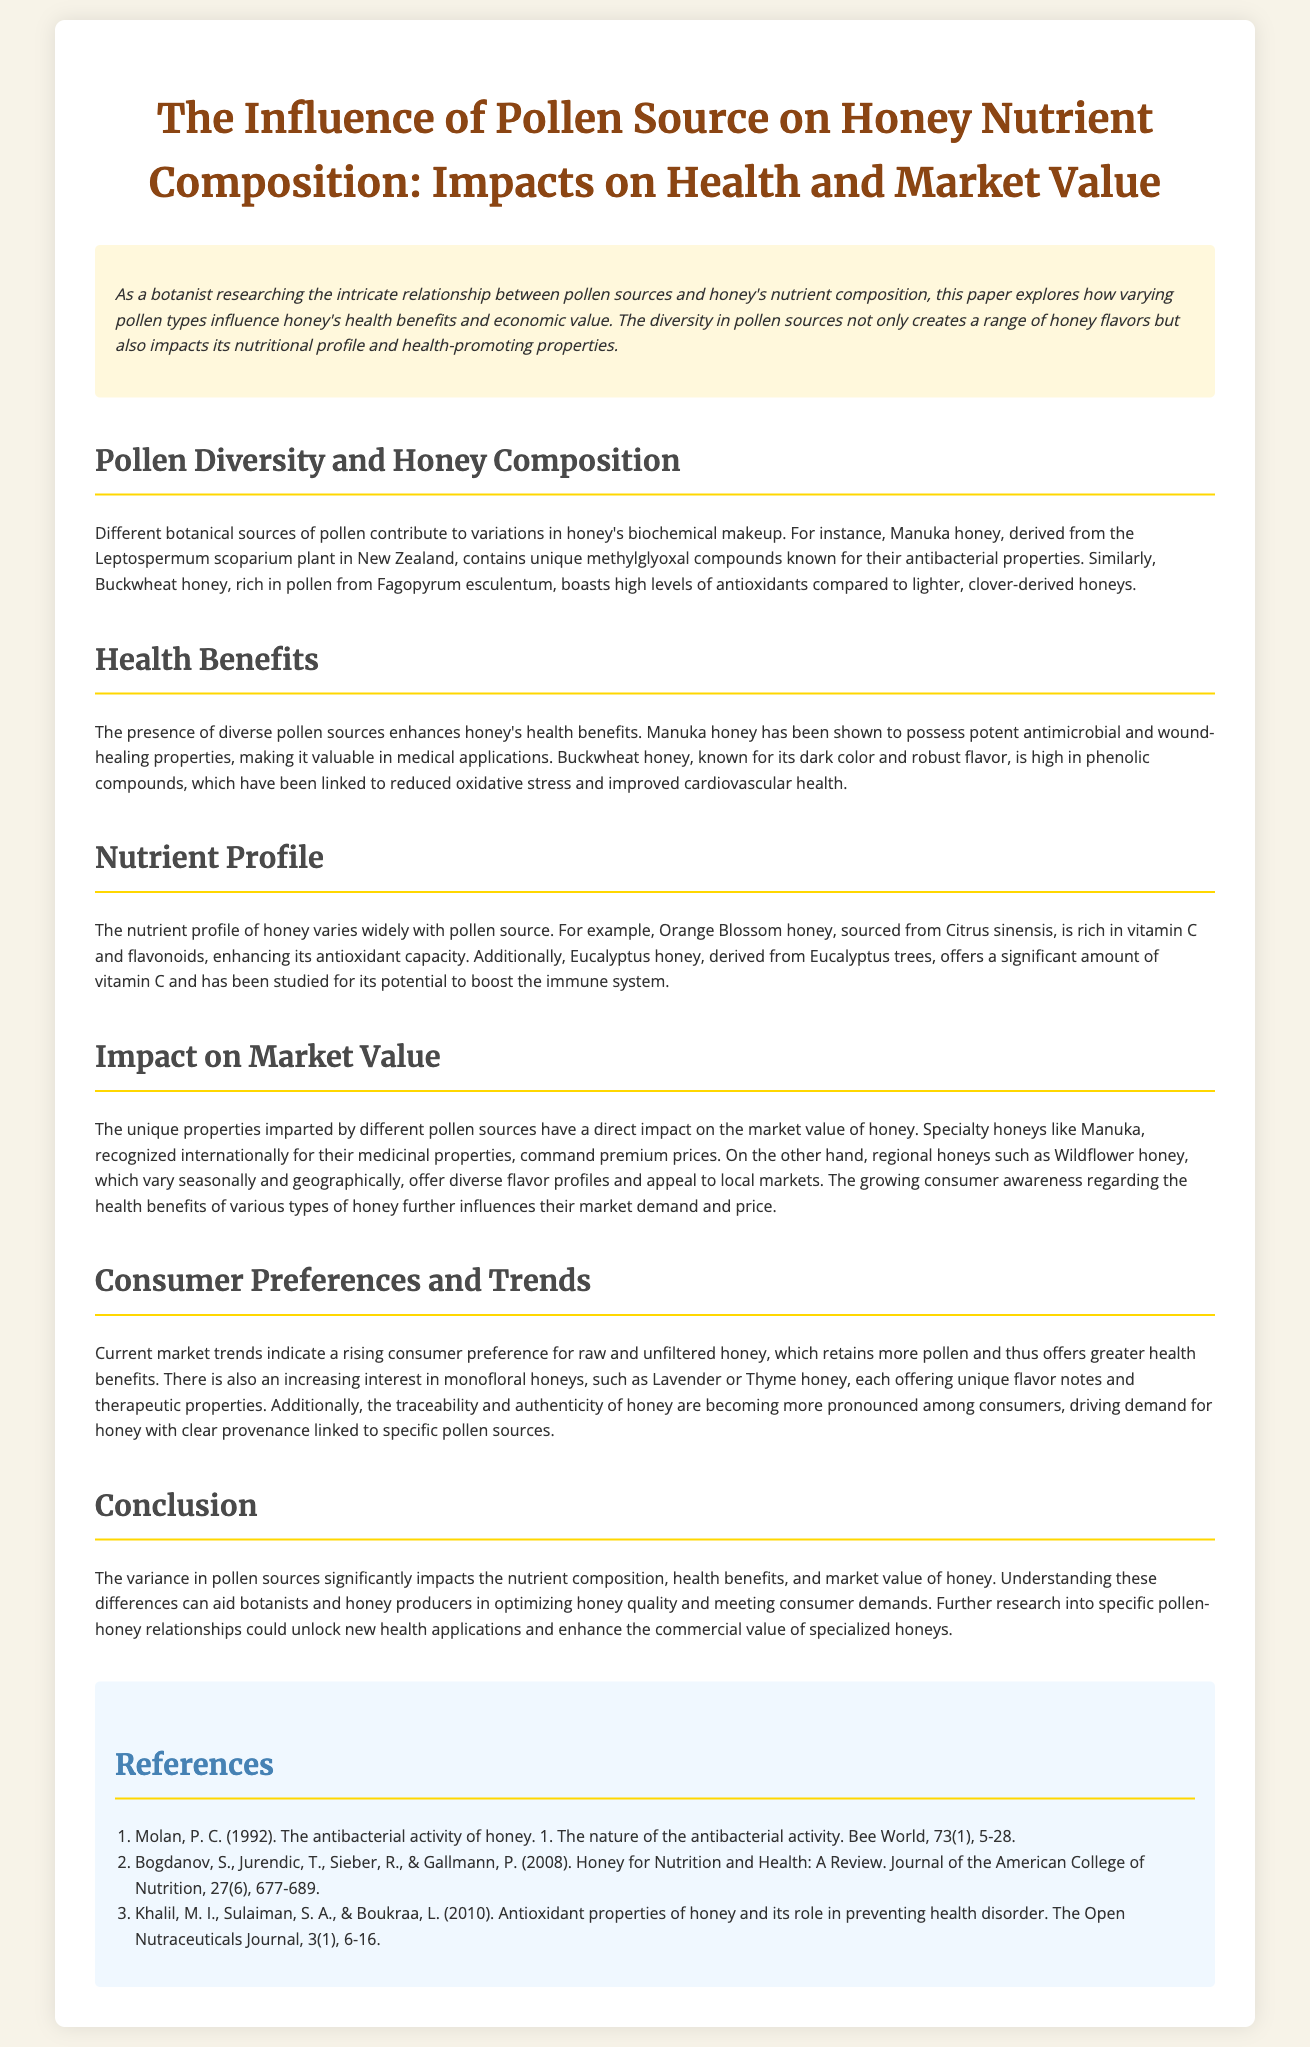What is the title of the whitepaper? The title of the whitepaper includes the main focus on pollen sources and honey's nutrient composition.
Answer: The Influence of Pollen Source on Honey Nutrient Composition: Impacts on Health and Market Value What unique compounds are found in Manuka honey? The document specifically mentions the unique compounds associated with Manuka honey, highlighting its distinctive properties.
Answer: Methylglyoxal Which honey is known for its high antioxidant levels? The document states that certain pollen sources contribute to higher antioxidant levels, with specific honey types mentioned.
Answer: Buckwheat honey What vitamin is Orange Blossom honey rich in? The nutrient content of Orange Blossom honey is detailed, indicating its specific beneficial components.
Answer: Vitamin C What do consumer preferences indicate about honey? The document discusses current market trends and consumer habits concerning honey attributes and choices.
Answer: Rising consumer preference for raw and unfiltered honey Which honey has been shown to possess potent antimicrobial properties? The health benefits section identifies specific honeys and their associated health effects.
Answer: Manuka honey What impact do pollen sources have on honey’s market value? The relationship between pollen sources and market value is discussed, determining how various attributes affect pricing.
Answer: Direct impact on market value Which botanical source is linked to Eucalyptus honey? The document provides specific examples of plants corresponding to different honey types.
Answer: Eucalyptus trees What are consumers increasingly interested in regarding honey? The document outlines shifting consumer interests and demands in honey purchases.
Answer: Monofloral honeys 